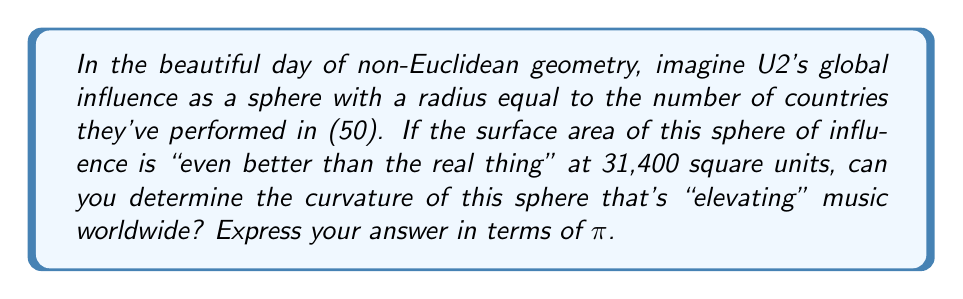Solve this math problem. Let's rock through this step-by-step, like U2 through their setlist:

1) First, recall the formula for the surface area of a sphere:
   $$ A = 4\pi r^2 $$
   Where A is the surface area and r is the radius.

2) We're given that the radius (r) is 50 units and the surface area (A) is 31,400 square units.

3) Let's plug these values into our equation:
   $$ 31,400 = 4\pi (50)^2 $$

4) Simplify the right side:
   $$ 31,400 = 4\pi (2,500) = 10,000\pi $$

5) Now, in non-Euclidean geometry, the Gaussian curvature (K) of a sphere is given by:
   $$ K = \frac{1}{r^2} $$

6) Plugging in our radius:
   $$ K = \frac{1}{50^2} = \frac{1}{2,500} $$

7) To express this in terms of π, let's use our result from step 4:
   $$ 31,400 = 10,000\pi $$
   $$ \pi = 3.14 $$

8) Now we can write our curvature as:
   $$ K = \frac{1}{2,500} = \frac{\pi}{7,850} $$

This curvature is as constant as U2's musical innovation!
Answer: $\frac{\pi}{7,850}$ 